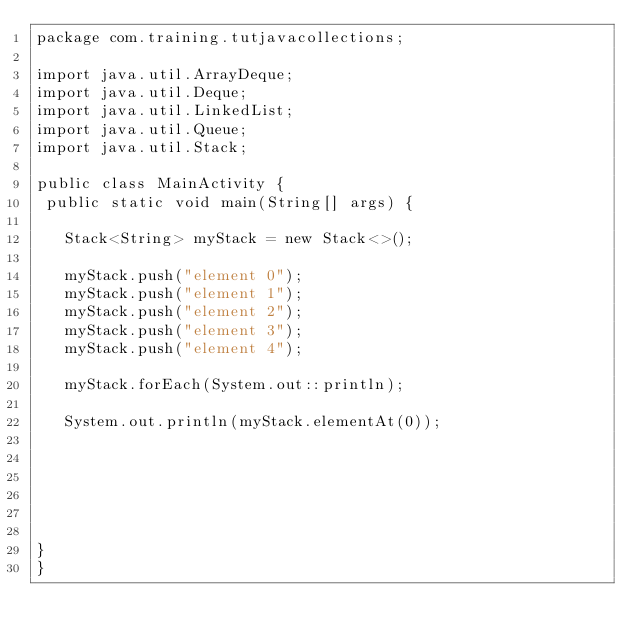<code> <loc_0><loc_0><loc_500><loc_500><_Java_>package com.training.tutjavacollections;

import java.util.ArrayDeque;
import java.util.Deque;
import java.util.LinkedList;
import java.util.Queue;
import java.util.Stack;

public class MainActivity {
 public static void main(String[] args) {
	
	 Stack<String> myStack = new Stack<>();
	 
	 myStack.push("element 0");
	 myStack.push("element 1");
	 myStack.push("element 2");
	 myStack.push("element 3");
	 myStack.push("element 4");
	 
	 myStack.forEach(System.out::println);
	 
	 System.out.println(myStack.elementAt(0));
	 
	 
	 
	 
	 
	 
}
}
</code> 